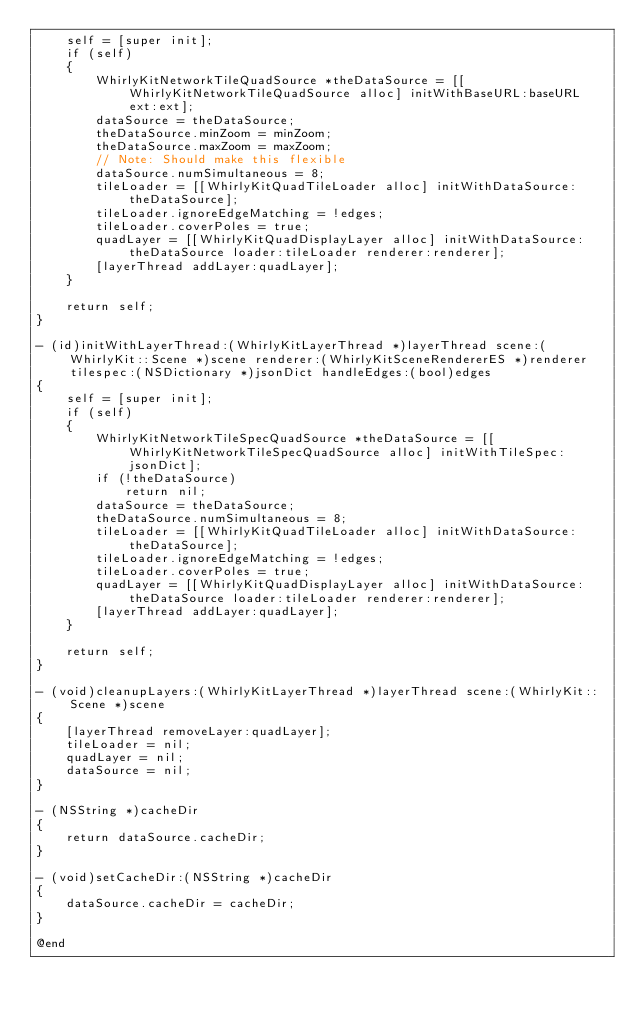<code> <loc_0><loc_0><loc_500><loc_500><_ObjectiveC_>    self = [super init];
    if (self)
    {
        WhirlyKitNetworkTileQuadSource *theDataSource = [[WhirlyKitNetworkTileQuadSource alloc] initWithBaseURL:baseURL ext:ext];
        dataSource = theDataSource;
        theDataSource.minZoom = minZoom;
        theDataSource.maxZoom = maxZoom;
        // Note: Should make this flexible
        dataSource.numSimultaneous = 8;
        tileLoader = [[WhirlyKitQuadTileLoader alloc] initWithDataSource:theDataSource];
        tileLoader.ignoreEdgeMatching = !edges;
        tileLoader.coverPoles = true;
        quadLayer = [[WhirlyKitQuadDisplayLayer alloc] initWithDataSource:theDataSource loader:tileLoader renderer:renderer];
        [layerThread addLayer:quadLayer];
    }
    
    return self;
}

- (id)initWithLayerThread:(WhirlyKitLayerThread *)layerThread scene:(WhirlyKit::Scene *)scene renderer:(WhirlyKitSceneRendererES *)renderer tilespec:(NSDictionary *)jsonDict handleEdges:(bool)edges
{
    self = [super init];
    if (self)
    {
        WhirlyKitNetworkTileSpecQuadSource *theDataSource = [[WhirlyKitNetworkTileSpecQuadSource alloc] initWithTileSpec:jsonDict];
        if (!theDataSource)
            return nil;
        dataSource = theDataSource;
        theDataSource.numSimultaneous = 8;
        tileLoader = [[WhirlyKitQuadTileLoader alloc] initWithDataSource:theDataSource];
        tileLoader.ignoreEdgeMatching = !edges;
        tileLoader.coverPoles = true;
        quadLayer = [[WhirlyKitQuadDisplayLayer alloc] initWithDataSource:theDataSource loader:tileLoader renderer:renderer];
        [layerThread addLayer:quadLayer];
    }
    
    return self;
}

- (void)cleanupLayers:(WhirlyKitLayerThread *)layerThread scene:(WhirlyKit::Scene *)scene
{
    [layerThread removeLayer:quadLayer];
    tileLoader = nil;
    quadLayer = nil;
    dataSource = nil;
}

- (NSString *)cacheDir
{
    return dataSource.cacheDir;
}

- (void)setCacheDir:(NSString *)cacheDir
{
    dataSource.cacheDir = cacheDir;
}

@end

</code> 